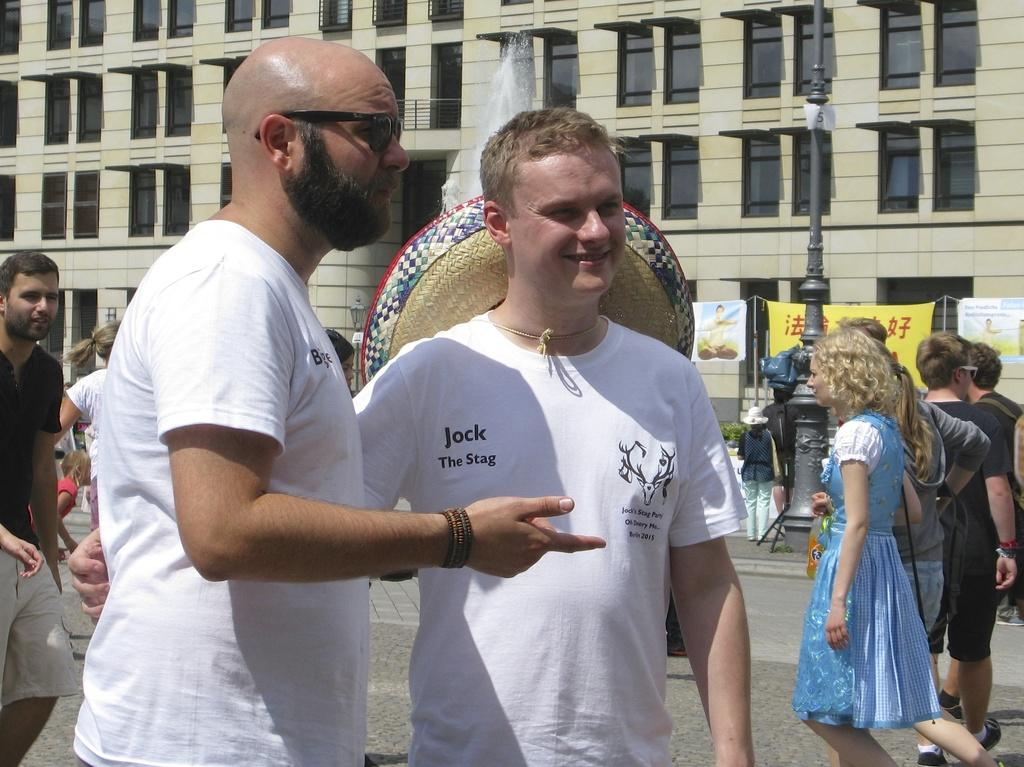How many people are standing in the image? There are 2 people standing in the image. What are the people wearing? Both people are wearing white t-shirts. Can you describe the background of the image? There are other people visible in the background, as well as a pole, a fountain, and a building. What type of heat is being generated by the shirt in the image? There is no shirt mentioned in the image, only white t-shirts worn by the two people. Additionally, shirts do not generate heat. 